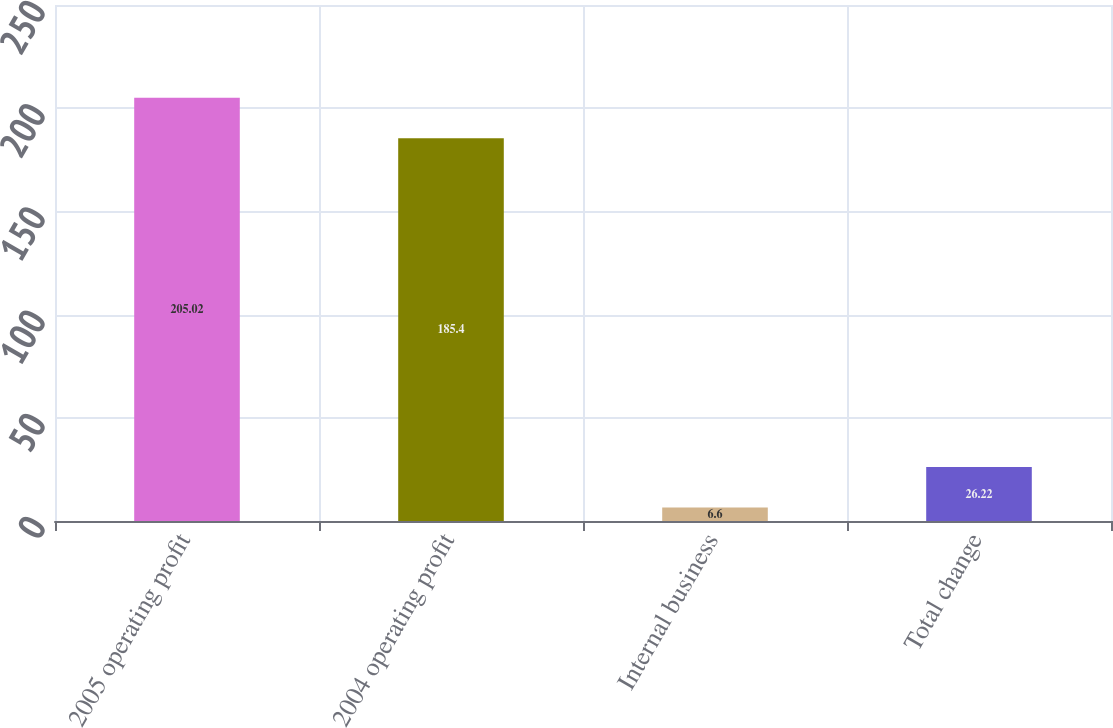<chart> <loc_0><loc_0><loc_500><loc_500><bar_chart><fcel>2005 operating profit<fcel>2004 operating profit<fcel>Internal business<fcel>Total change<nl><fcel>205.02<fcel>185.4<fcel>6.6<fcel>26.22<nl></chart> 